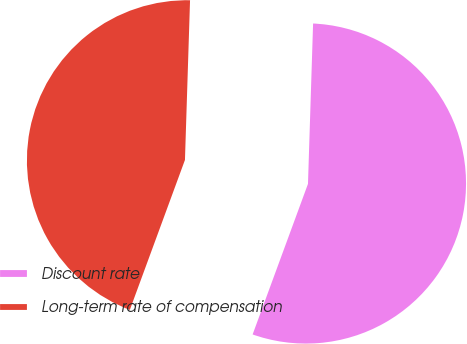<chart> <loc_0><loc_0><loc_500><loc_500><pie_chart><fcel>Discount rate<fcel>Long-term rate of compensation<nl><fcel>55.1%<fcel>44.9%<nl></chart> 